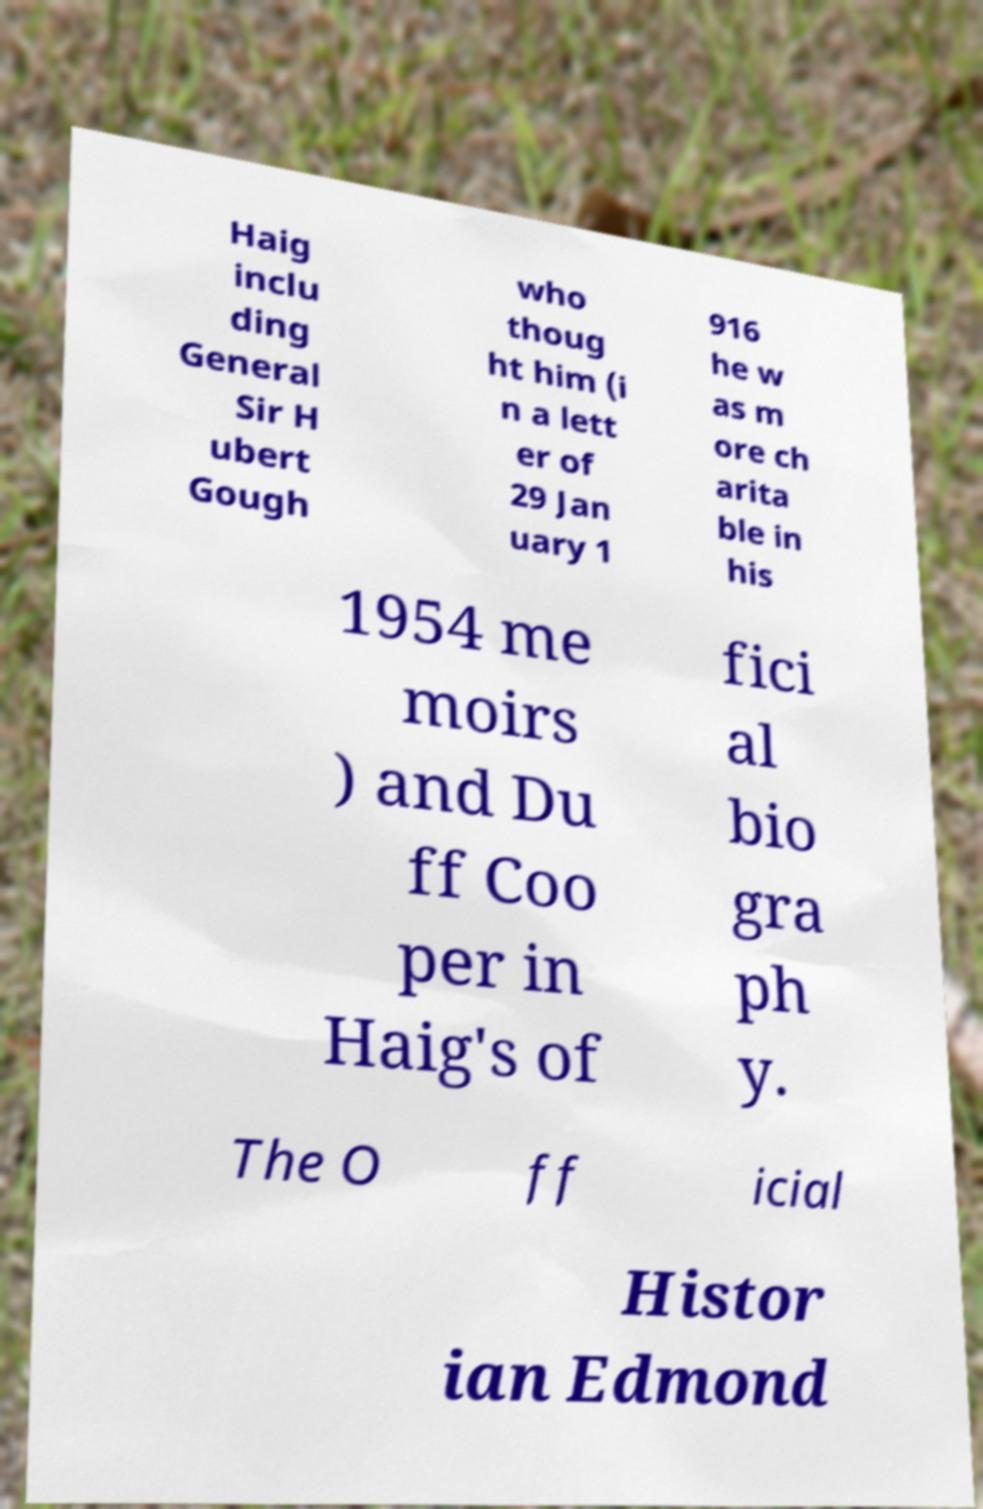Can you read and provide the text displayed in the image?This photo seems to have some interesting text. Can you extract and type it out for me? Haig inclu ding General Sir H ubert Gough who thoug ht him (i n a lett er of 29 Jan uary 1 916 he w as m ore ch arita ble in his 1954 me moirs ) and Du ff Coo per in Haig's of fici al bio gra ph y. The O ff icial Histor ian Edmond 